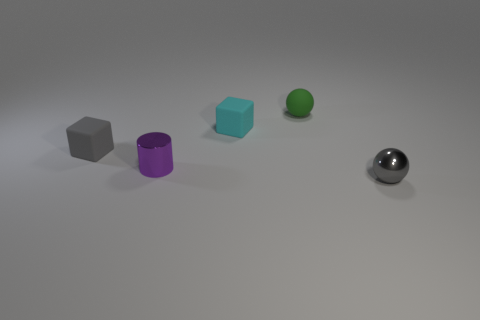Are there any other small spheres of the same color as the metal ball?
Provide a short and direct response. No. Is there a matte sphere?
Make the answer very short. Yes. Is the tiny ball that is in front of the cylinder made of the same material as the tiny cylinder?
Keep it short and to the point. Yes. There is a rubber thing that is the same color as the metal ball; what is its size?
Give a very brief answer. Small. How many cyan blocks have the same size as the green matte thing?
Your answer should be compact. 1. Are there an equal number of tiny cyan cubes that are in front of the shiny sphere and large purple rubber balls?
Keep it short and to the point. Yes. How many things are both on the left side of the cyan thing and in front of the gray matte object?
Ensure brevity in your answer.  1. The gray object that is the same material as the small green sphere is what size?
Keep it short and to the point. Small. What number of purple metal objects are the same shape as the small gray matte object?
Keep it short and to the point. 0. Are there more tiny cyan matte cubes to the right of the cyan thing than purple blocks?
Make the answer very short. No. 